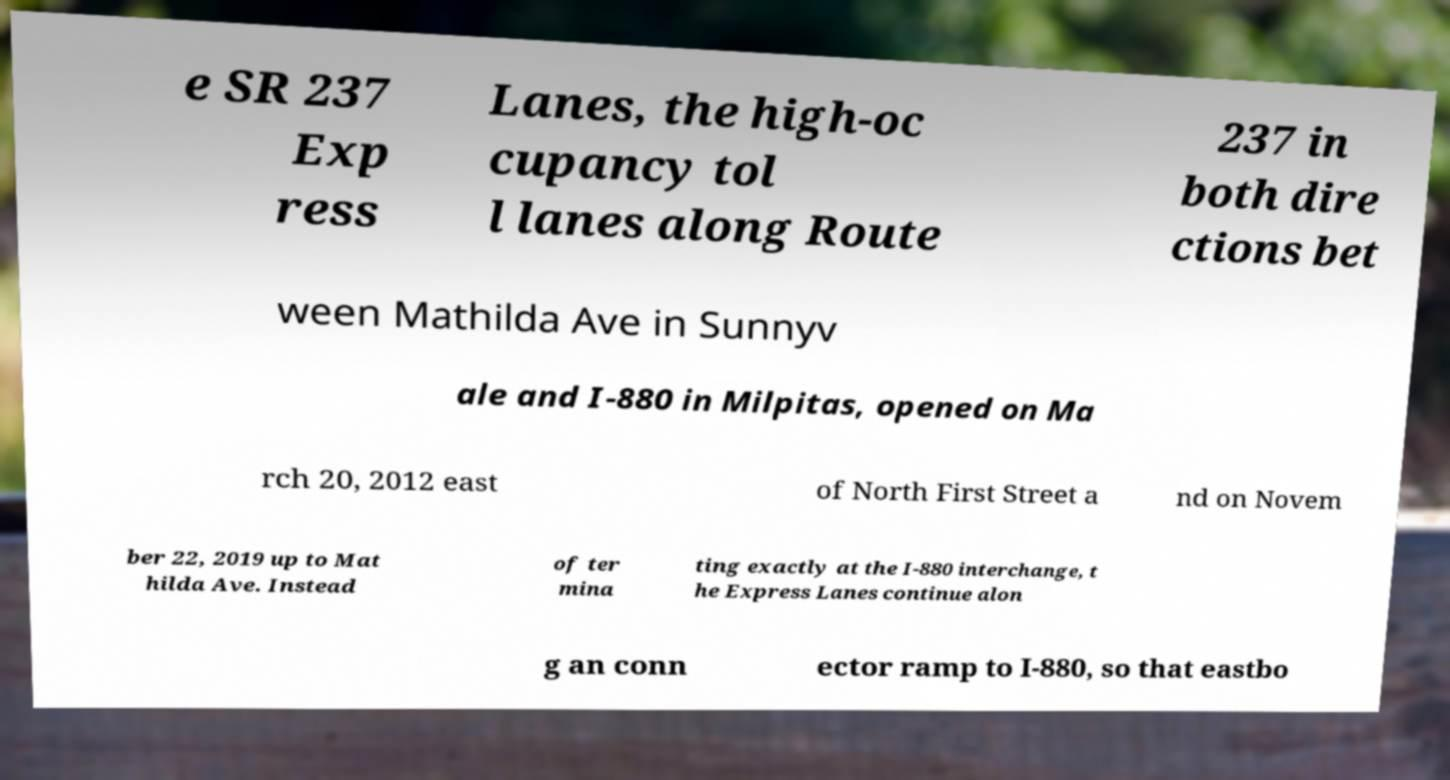There's text embedded in this image that I need extracted. Can you transcribe it verbatim? e SR 237 Exp ress Lanes, the high-oc cupancy tol l lanes along Route 237 in both dire ctions bet ween Mathilda Ave in Sunnyv ale and I-880 in Milpitas, opened on Ma rch 20, 2012 east of North First Street a nd on Novem ber 22, 2019 up to Mat hilda Ave. Instead of ter mina ting exactly at the I-880 interchange, t he Express Lanes continue alon g an conn ector ramp to I-880, so that eastbo 